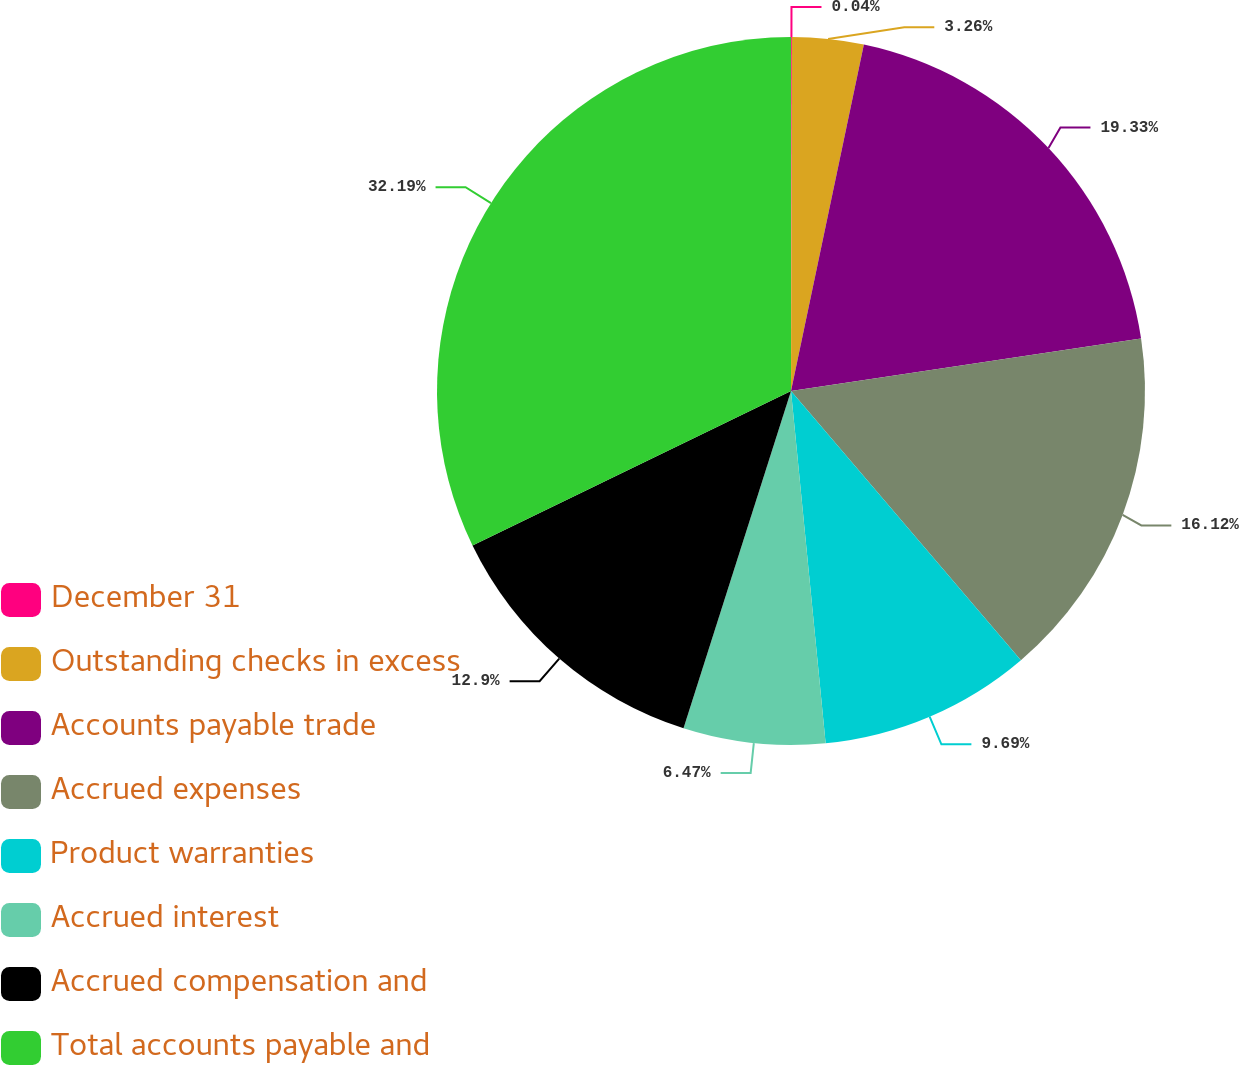Convert chart. <chart><loc_0><loc_0><loc_500><loc_500><pie_chart><fcel>December 31<fcel>Outstanding checks in excess<fcel>Accounts payable trade<fcel>Accrued expenses<fcel>Product warranties<fcel>Accrued interest<fcel>Accrued compensation and<fcel>Total accounts payable and<nl><fcel>0.04%<fcel>3.26%<fcel>19.33%<fcel>16.12%<fcel>9.69%<fcel>6.47%<fcel>12.9%<fcel>32.19%<nl></chart> 